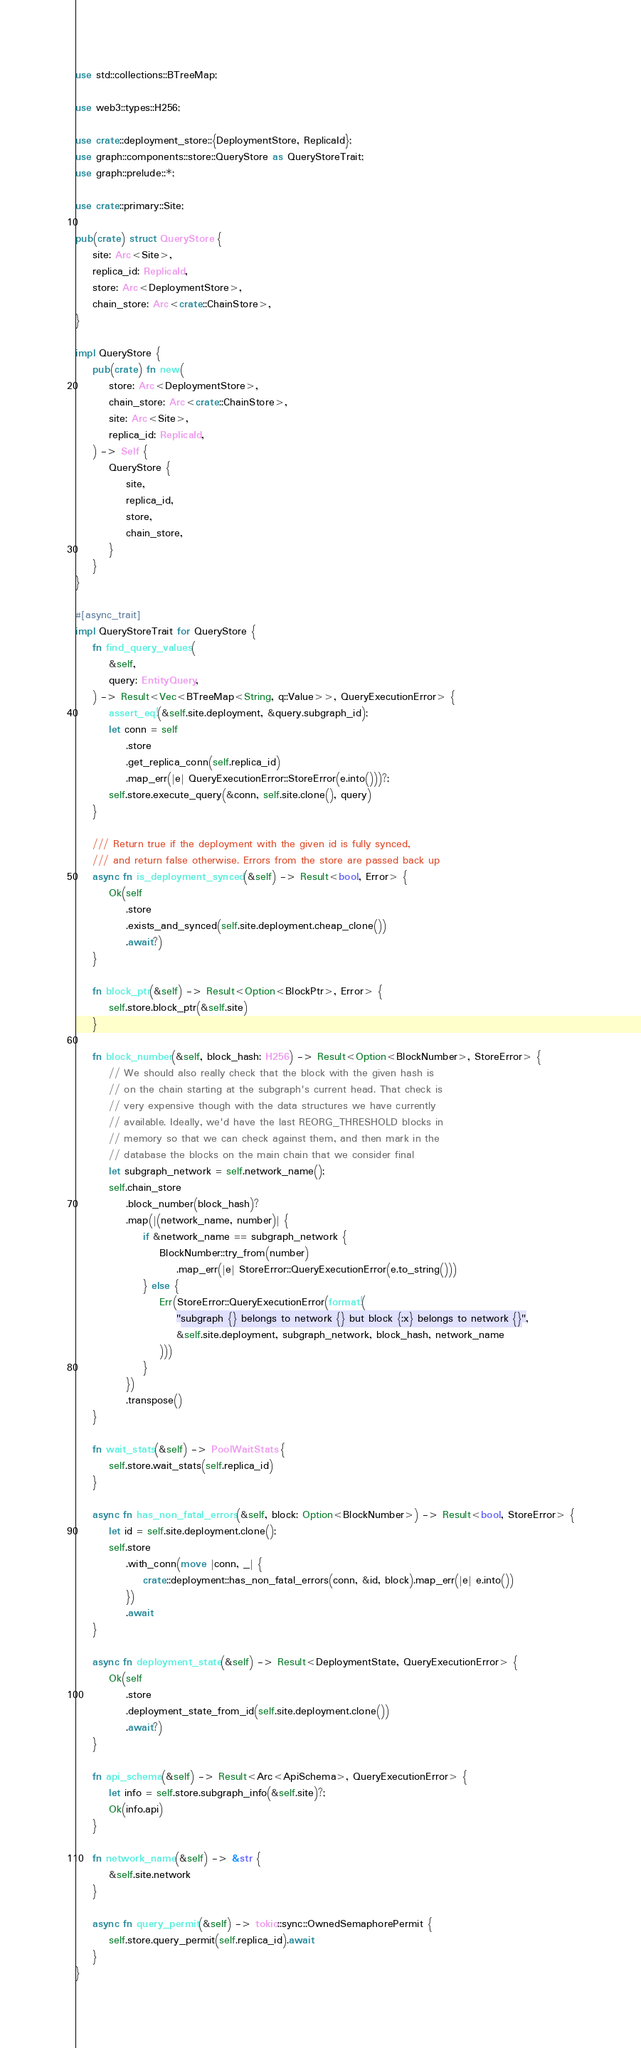Convert code to text. <code><loc_0><loc_0><loc_500><loc_500><_Rust_>use std::collections::BTreeMap;

use web3::types::H256;

use crate::deployment_store::{DeploymentStore, ReplicaId};
use graph::components::store::QueryStore as QueryStoreTrait;
use graph::prelude::*;

use crate::primary::Site;

pub(crate) struct QueryStore {
    site: Arc<Site>,
    replica_id: ReplicaId,
    store: Arc<DeploymentStore>,
    chain_store: Arc<crate::ChainStore>,
}

impl QueryStore {
    pub(crate) fn new(
        store: Arc<DeploymentStore>,
        chain_store: Arc<crate::ChainStore>,
        site: Arc<Site>,
        replica_id: ReplicaId,
    ) -> Self {
        QueryStore {
            site,
            replica_id,
            store,
            chain_store,
        }
    }
}

#[async_trait]
impl QueryStoreTrait for QueryStore {
    fn find_query_values(
        &self,
        query: EntityQuery,
    ) -> Result<Vec<BTreeMap<String, q::Value>>, QueryExecutionError> {
        assert_eq!(&self.site.deployment, &query.subgraph_id);
        let conn = self
            .store
            .get_replica_conn(self.replica_id)
            .map_err(|e| QueryExecutionError::StoreError(e.into()))?;
        self.store.execute_query(&conn, self.site.clone(), query)
    }

    /// Return true if the deployment with the given id is fully synced,
    /// and return false otherwise. Errors from the store are passed back up
    async fn is_deployment_synced(&self) -> Result<bool, Error> {
        Ok(self
            .store
            .exists_and_synced(self.site.deployment.cheap_clone())
            .await?)
    }

    fn block_ptr(&self) -> Result<Option<BlockPtr>, Error> {
        self.store.block_ptr(&self.site)
    }

    fn block_number(&self, block_hash: H256) -> Result<Option<BlockNumber>, StoreError> {
        // We should also really check that the block with the given hash is
        // on the chain starting at the subgraph's current head. That check is
        // very expensive though with the data structures we have currently
        // available. Ideally, we'd have the last REORG_THRESHOLD blocks in
        // memory so that we can check against them, and then mark in the
        // database the blocks on the main chain that we consider final
        let subgraph_network = self.network_name();
        self.chain_store
            .block_number(block_hash)?
            .map(|(network_name, number)| {
                if &network_name == subgraph_network {
                    BlockNumber::try_from(number)
                        .map_err(|e| StoreError::QueryExecutionError(e.to_string()))
                } else {
                    Err(StoreError::QueryExecutionError(format!(
                        "subgraph {} belongs to network {} but block {:x} belongs to network {}",
                        &self.site.deployment, subgraph_network, block_hash, network_name
                    )))
                }
            })
            .transpose()
    }

    fn wait_stats(&self) -> PoolWaitStats {
        self.store.wait_stats(self.replica_id)
    }

    async fn has_non_fatal_errors(&self, block: Option<BlockNumber>) -> Result<bool, StoreError> {
        let id = self.site.deployment.clone();
        self.store
            .with_conn(move |conn, _| {
                crate::deployment::has_non_fatal_errors(conn, &id, block).map_err(|e| e.into())
            })
            .await
    }

    async fn deployment_state(&self) -> Result<DeploymentState, QueryExecutionError> {
        Ok(self
            .store
            .deployment_state_from_id(self.site.deployment.clone())
            .await?)
    }

    fn api_schema(&self) -> Result<Arc<ApiSchema>, QueryExecutionError> {
        let info = self.store.subgraph_info(&self.site)?;
        Ok(info.api)
    }

    fn network_name(&self) -> &str {
        &self.site.network
    }

    async fn query_permit(&self) -> tokio::sync::OwnedSemaphorePermit {
        self.store.query_permit(self.replica_id).await
    }
}
</code> 